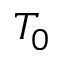Convert formula to latex. <formula><loc_0><loc_0><loc_500><loc_500>T _ { 0 }</formula> 